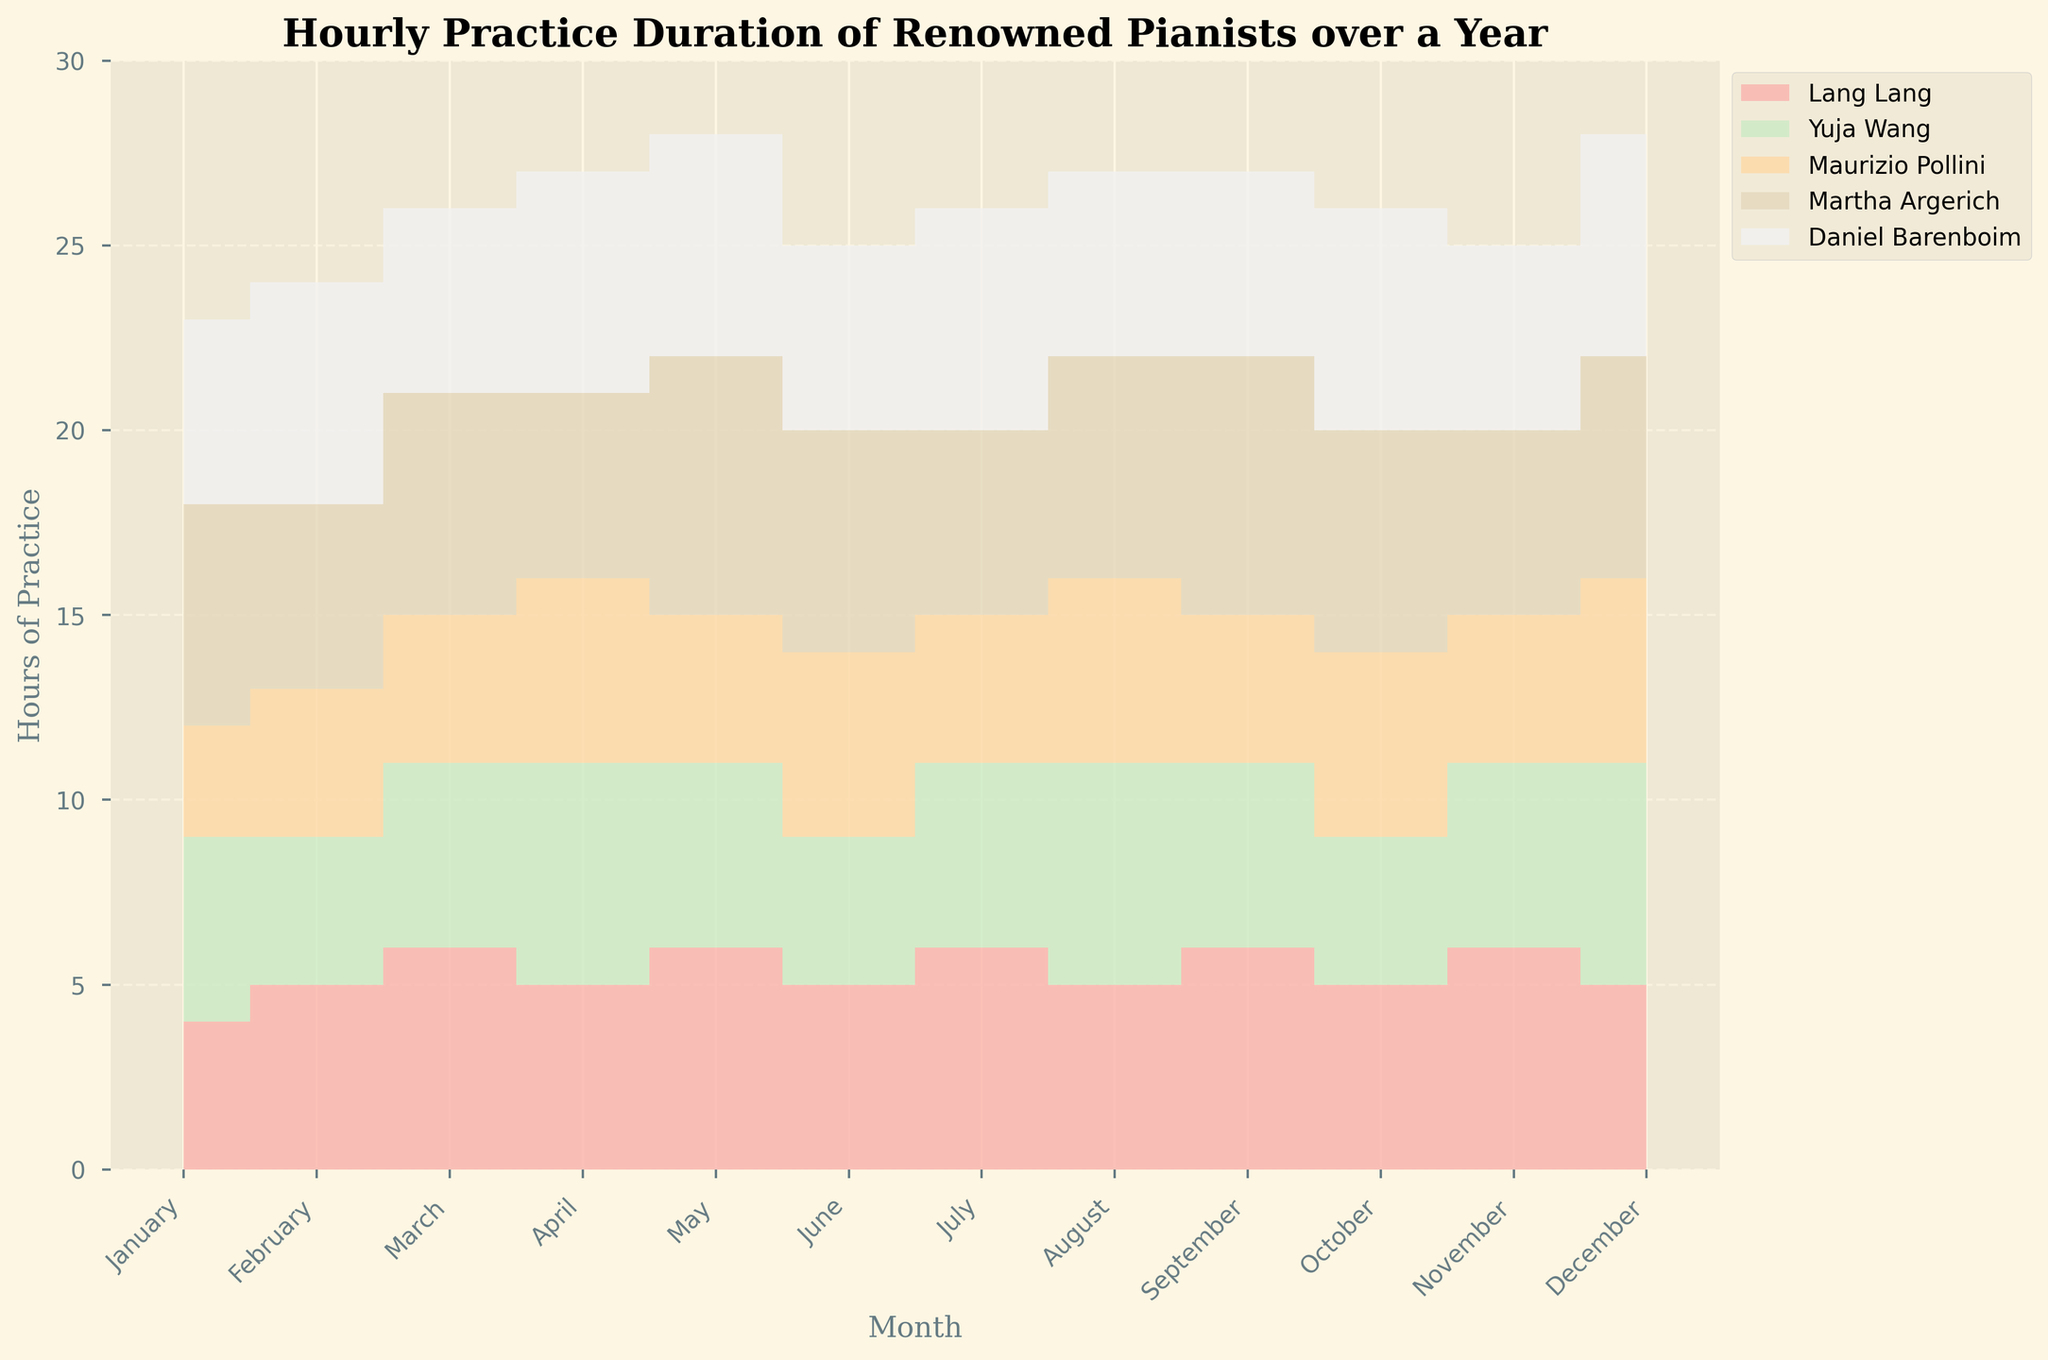What is the title of the chart? The title is located at the top of the chart, and it provides a summary of what the chart is about. Here, it states "Hourly Practice Duration of Renowned Pianists over a Year".
Answer: Hourly Practice Duration of Renowned Pianists over a Year What is the time period covered in the data? The x-axis of the chart shows the months of the year from January to December, indicating that the data covers one year.
Answer: One year Which pianist practiced the most in May? In May, look for the highest peak among all the colored areas in the corresponding month. Martha Argerich has the highest value with 7 hours.
Answer: Martha Argerich Which month did Yuja Wang have the highest practice duration? Observe Yuja Wang's stack (one specific color) across all months and identify the highest point. This occurs in April and December where she practiced for 6 hours each.
Answer: April and December Compare Daniel Barenboim's practice in January and November. Which month did he practice more and by how many hours? Check the stack heights for Daniel Barenboim in January and November. In January, he practiced 5 hours, and in November, he practiced 5 hours. The practice duration is the same in both months.
Answer: Same duration, 0 hours difference On average, how many hours did Lang Lang practice per month? Sum up Lang Lang's practice hours for all months and then divide by 12. The total is 61 hours: (4+5+6+5+6+5+6+5+6+5+6+5). The average is 61/12 = 5.08 hours.
Answer: 5.08 hours Which two pianists have the least difference in their practice duration in December? In December, compare the practice hours of all pianists. Yuja Wang and Martha Argerich are both at 6 hours, making the difference 0.
Answer: Yuja Wang and Martha Argerich During which month did Martha Argerich practice the least? Identify the lowest value of Martha Argerich's stack across all months. This occurs in February, July, November, and December, where she practiced 5 hours.
Answer: February, July, November, and December Calculate the total practice hours for all pianists combined in September. Sum the practice hours for all pianists in September: Lang Lang (6) + Yuja Wang (5) + Maurizio Pollini (4) + Martha Argerich (7) + Daniel Barenboim (5). The total is 6 + 5 + 4 + 7 + 5 = 27 hours.
Answer: 27 hours In which month did all pianists combined practice the least? By visual inspection, identify the month with the smallest combined stack height. This occurs in January, with the sum being 4+5+3+6+5 = 23 hours.
Answer: January 